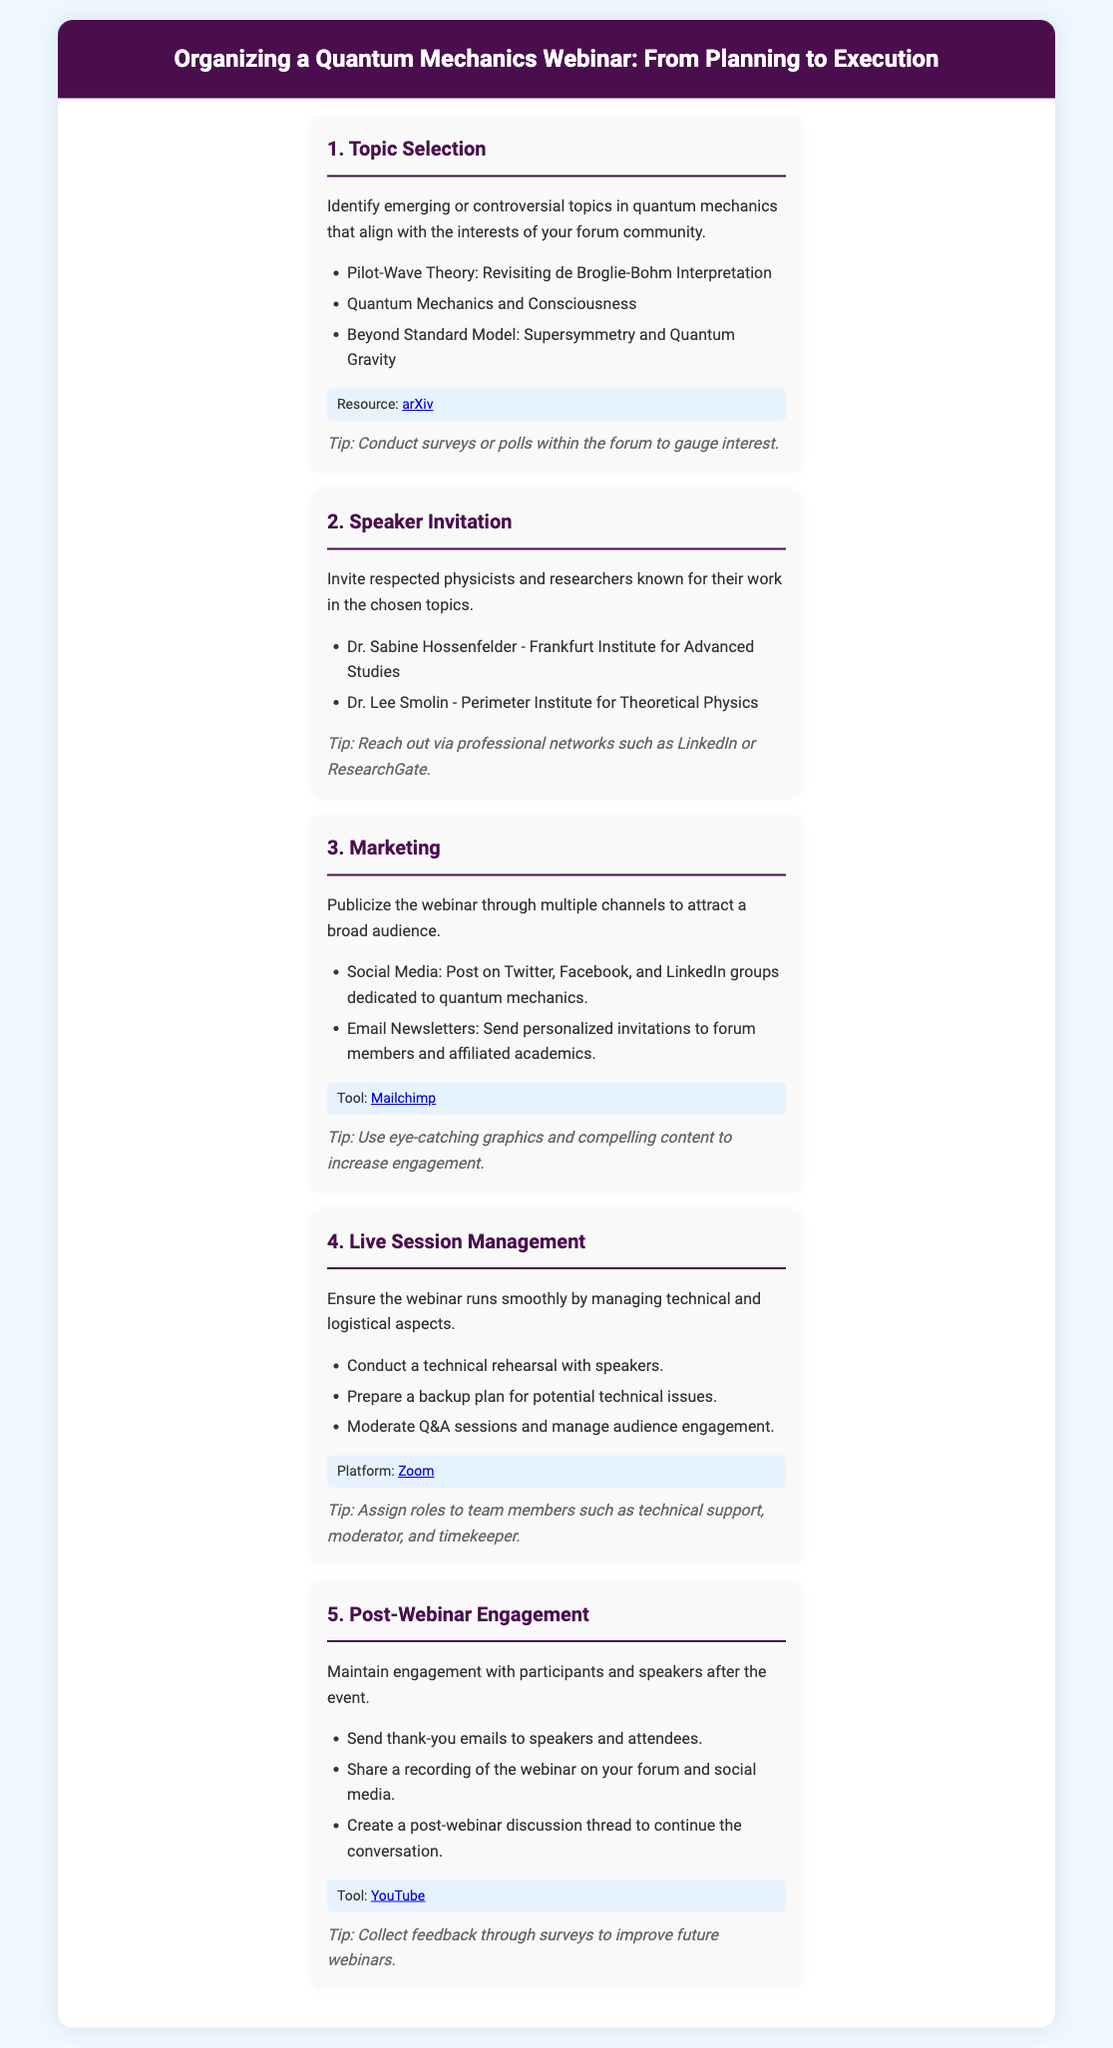What is the first step in organizing the webinar? The first step outlined in the infographic is Topic Selection, which involves identifying emerging or controversial topics in quantum mechanics.
Answer: Topic Selection Which platform is suggested for Live Session Management? The infographic recommends using Zoom as the platform for managing the live session.
Answer: Zoom Who is one of the suggested speakers for the webinar? The document lists Dr. Sabine Hossenfelder as a respected physicist to invite as a speaker.
Answer: Dr. Sabine Hossenfelder What marketing tool is mentioned for publicizing the webinar? The infographic mentions Mailchimp as a tool for marketing and sending email newsletters.
Answer: Mailchimp What is a recommended action during Post-Webinar Engagement? A suggested action in post-webinar engagement is to send thank-you emails to speakers and attendees.
Answer: Send thank-you emails What is a tip for Topic Selection? The infographic suggests conducting surveys or polls within the forum to gauge interest as a tip for topic selection.
Answer: Conduct surveys or polls How many main steps are included in the infographic? The infographic outlines five main steps for organizing the webinar.
Answer: Five What should be prepared as a backup during Live Session Management? A backup plan for potential technical issues should be prepared as per the infographic.
Answer: Backup plan What kind of content should be used for marketing? The document advises using eye-catching graphics and compelling content to increase engagement during marketing.
Answer: Eye-catching graphics and compelling content 